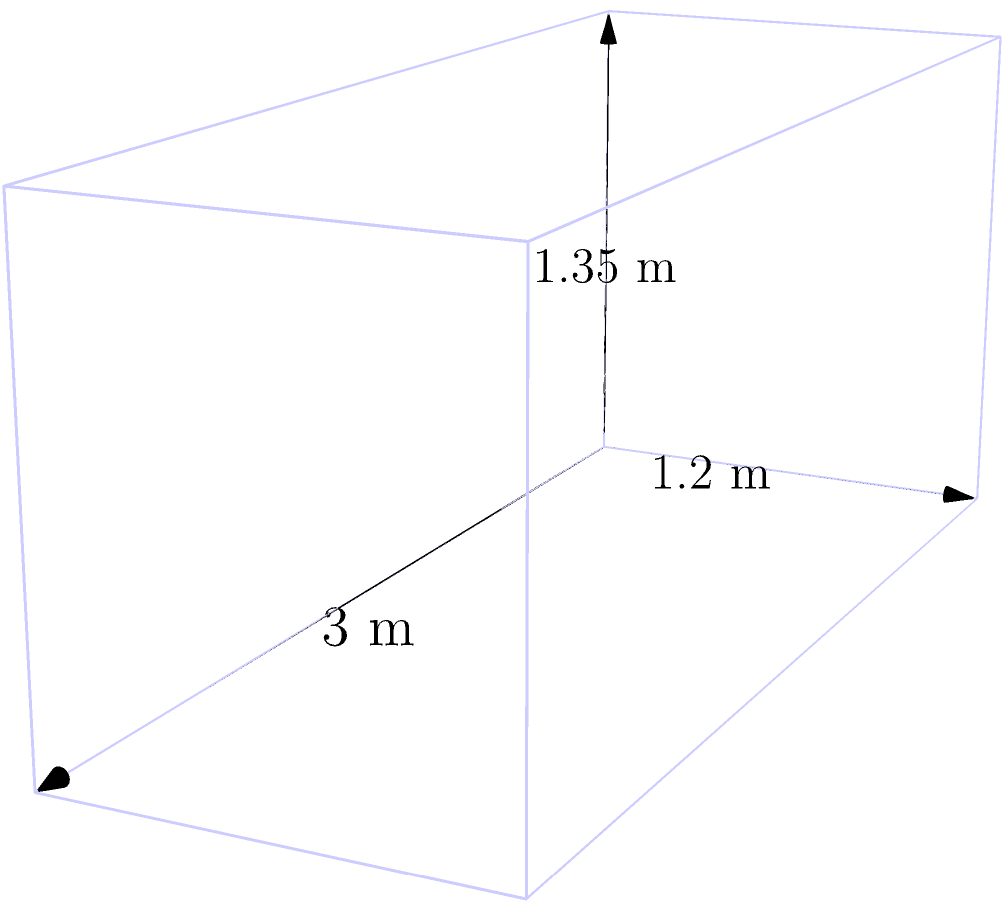As you prepare for your gymnastics routine, you notice the vault box in your practice area. Imagining it as a canvas for your next painting project, you decide to calculate its volume. Given that the vault box is 3 meters long, 1.2 meters wide, and 1.35 meters high, what is its volume in cubic meters? To calculate the volume of a rectangular prism (which is the shape of the gymnastics vault box), we use the formula:

$$V = l \times w \times h$$

Where:
$V$ = volume
$l$ = length
$w$ = width
$h$ = height

Given dimensions:
Length ($l$) = 3 meters
Width ($w$) = 1.2 meters
Height ($h$) = 1.35 meters

Let's substitute these values into the formula:

$$V = 3 \times 1.2 \times 1.35$$

Now, let's calculate:

$$V = 3 \times 1.2 \times 1.35 = 3.6 \times 1.35 = 4.86$$

Therefore, the volume of the gymnastics vault box is 4.86 cubic meters.
Answer: 4.86 m³ 